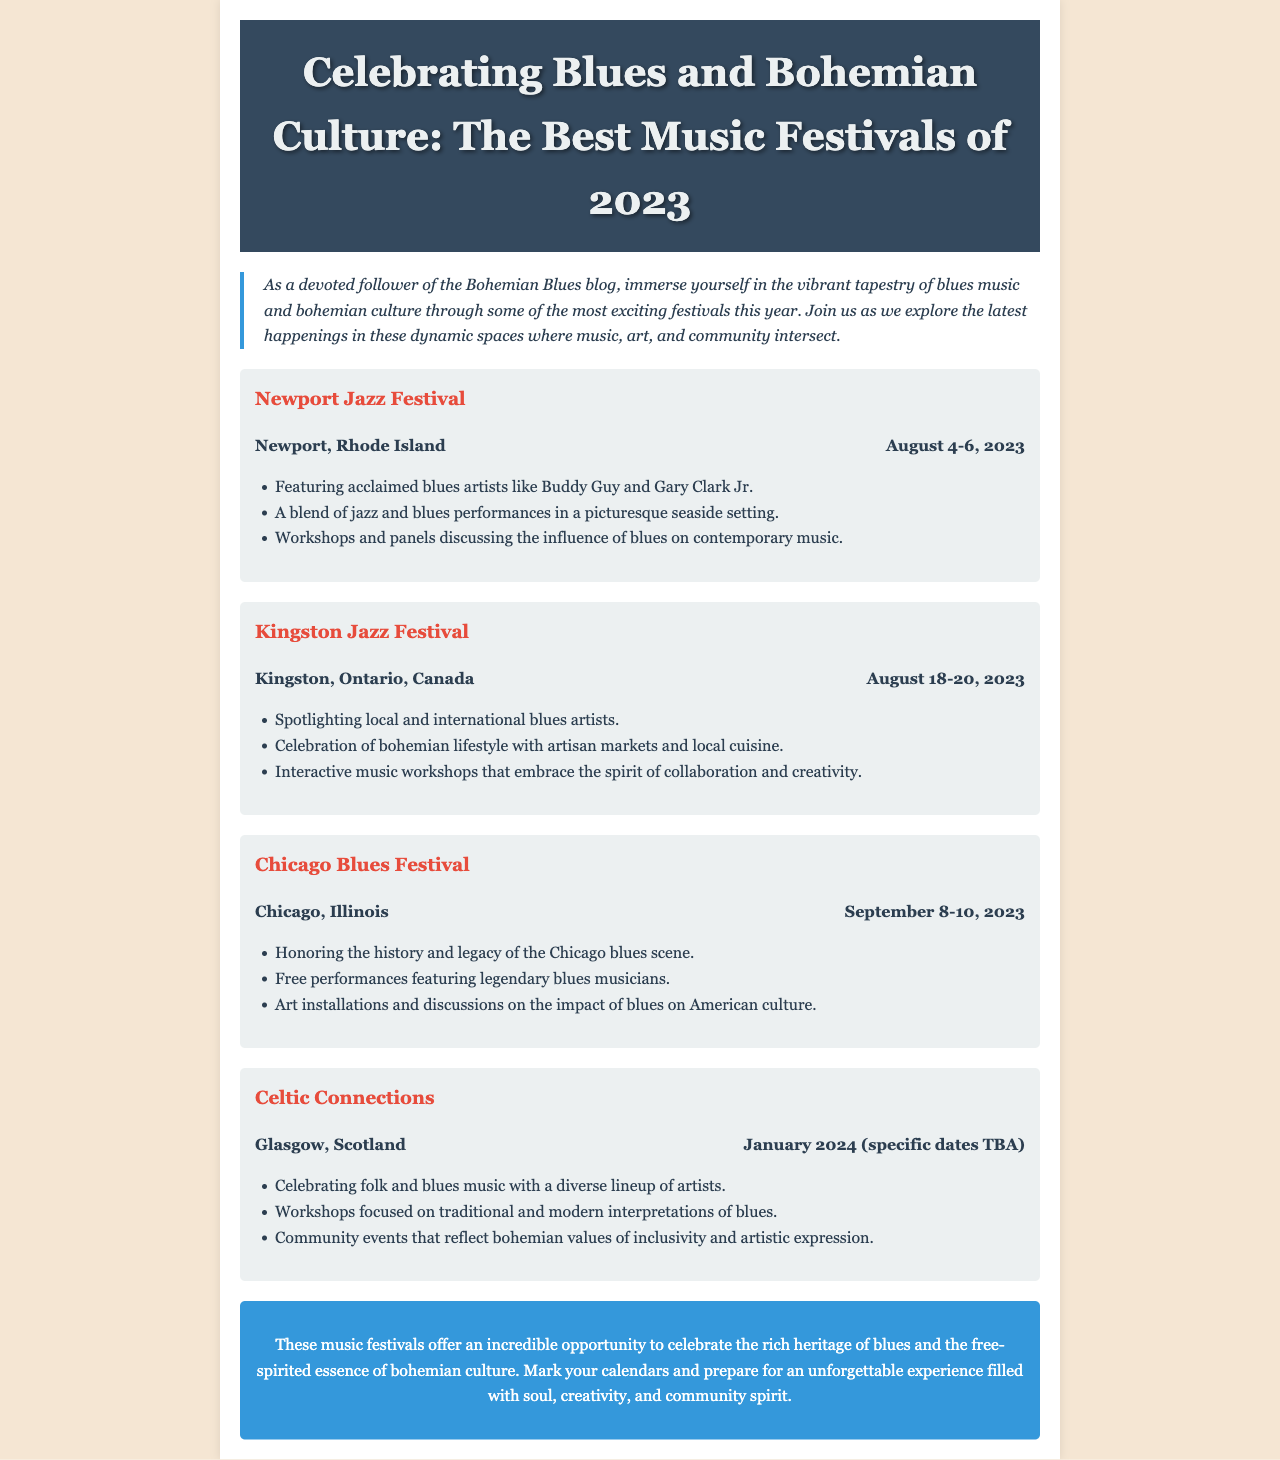What is the title of the newsletter? The title is the main heading at the top of the document, which highlights the focus on music festivals.
Answer: Celebrating Blues and Bohemian Culture: The Best Music Festivals of 2023 Where is the Newport Jazz Festival held? The location of each festival is specified within the festival section for Newport.
Answer: Newport, Rhode Island What are the dates for the Chicago Blues Festival? The specific dates are provided in the festival information section for Chicago.
Answer: September 8-10, 2023 Which festival features Buddy Guy and Gary Clark Jr.? The festival line-up includes specific artists mentioned in the Newport Jazz Festival section.
Answer: Newport Jazz Festival Which festival takes place in January 2024? This implies reasoning about the festival timelines included in the document.
Answer: Celtic Connections What type of cuisine is celebrated at the Kingston Jazz Festival? This is inferred based on the mention of local cuisine in the context of the festival.
Answer: Local cuisine How many blues artists are spotlighted in the Kingston Jazz Festival? The text mentions both local and international artists at the Kingston Jazz Festival without specifying a number, thus requires interpretation.
Answer: Not specified What theme is emphasized at the Chicago Blues Festival? This interprets the focus of the festival regarding its cultural heritage.
Answer: History and legacy of the Chicago blues scene 